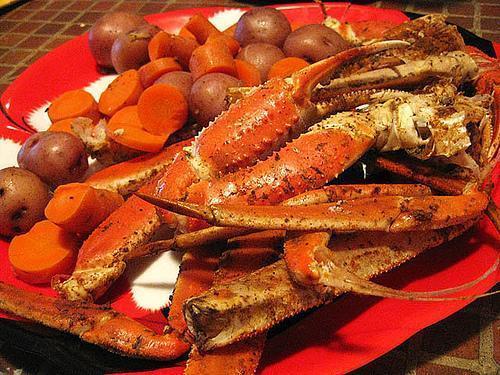How many carrots are in the photo?
Give a very brief answer. 3. 